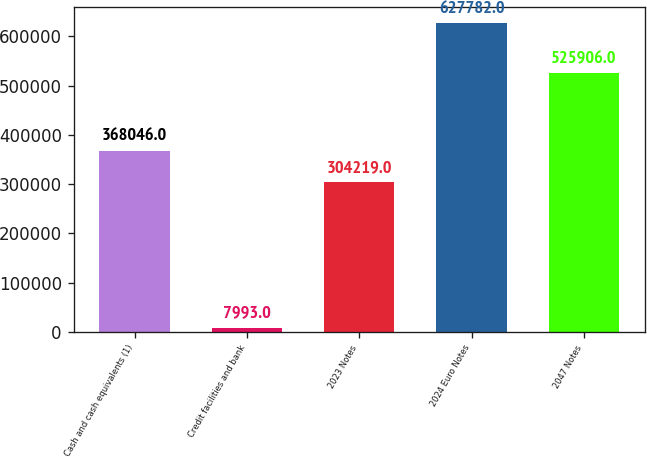<chart> <loc_0><loc_0><loc_500><loc_500><bar_chart><fcel>Cash and cash equivalents (1)<fcel>Credit facilities and bank<fcel>2023 Notes<fcel>2024 Euro Notes<fcel>2047 Notes<nl><fcel>368046<fcel>7993<fcel>304219<fcel>627782<fcel>525906<nl></chart> 